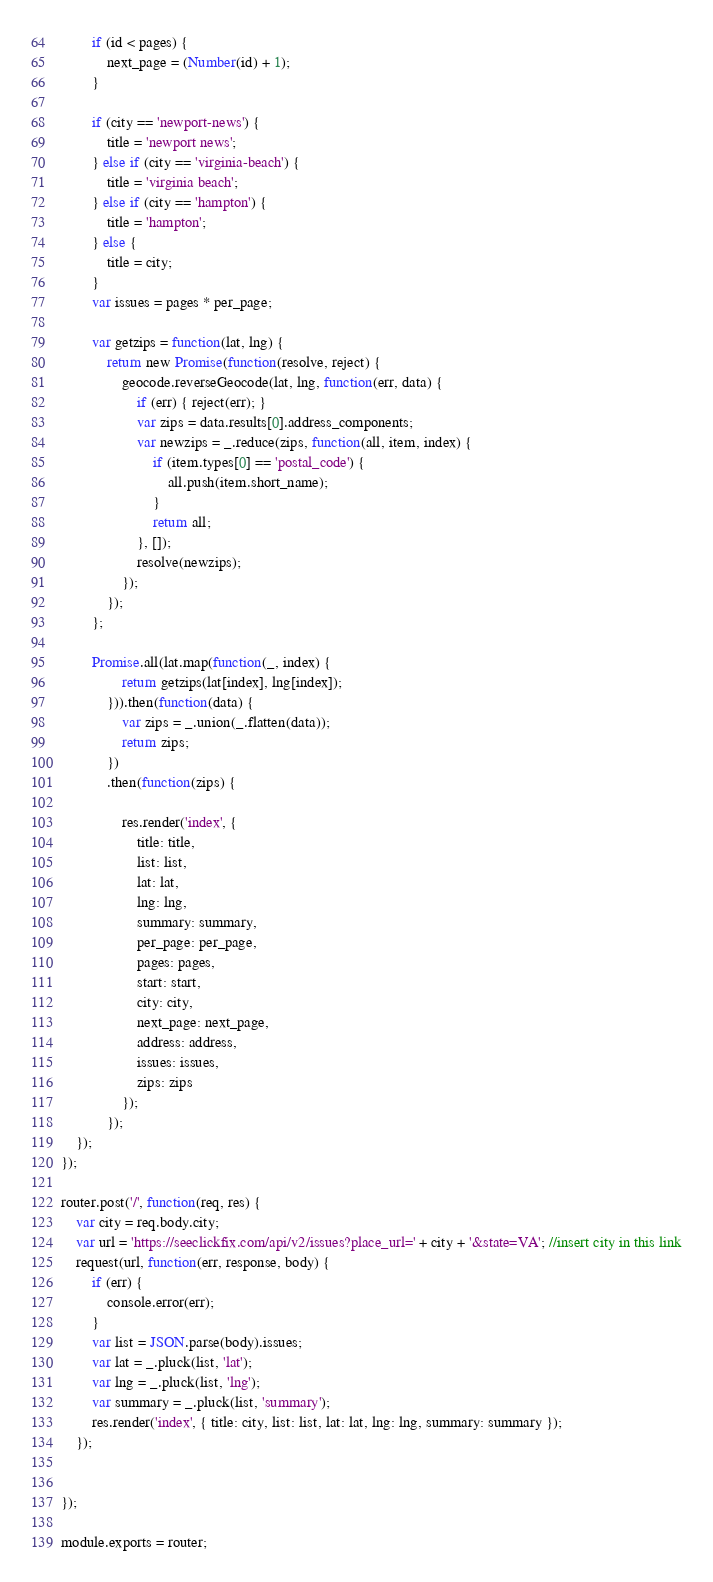Convert code to text. <code><loc_0><loc_0><loc_500><loc_500><_JavaScript_>        if (id < pages) {
            next_page = (Number(id) + 1);
        }

        if (city == 'newport-news') {
            title = 'newport news';
        } else if (city == 'virginia-beach') {
            title = 'virginia beach';
        } else if (city == 'hampton') {
            title = 'hampton';
        } else {
            title = city;
        }
        var issues = pages * per_page;

        var getzips = function(lat, lng) {
            return new Promise(function(resolve, reject) {
                geocode.reverseGeocode(lat, lng, function(err, data) {
                    if (err) { reject(err); }
                    var zips = data.results[0].address_components;
                    var newzips = _.reduce(zips, function(all, item, index) {
                        if (item.types[0] == 'postal_code') {
                            all.push(item.short_name);
                        }
                        return all;
                    }, []);
                    resolve(newzips);
                });
            });
        };

        Promise.all(lat.map(function(_, index) {
                return getzips(lat[index], lng[index]);
            })).then(function(data) {
                var zips = _.union(_.flatten(data));
                return zips;
            })
            .then(function(zips) {

                res.render('index', {
                    title: title,
                    list: list,
                    lat: lat,
                    lng: lng,
                    summary: summary,
                    per_page: per_page,
                    pages: pages,
                    start: start,
                    city: city,
                    next_page: next_page,
                    address: address,
                    issues: issues,
                    zips: zips
                });
            });
    });
});

router.post('/', function(req, res) {
    var city = req.body.city;
    var url = 'https://seeclickfix.com/api/v2/issues?place_url=' + city + '&state=VA'; //insert city in this link
    request(url, function(err, response, body) {
        if (err) {
            console.error(err);
        }
        var list = JSON.parse(body).issues;
        var lat = _.pluck(list, 'lat');
        var lng = _.pluck(list, 'lng');
        var summary = _.pluck(list, 'summary');
        res.render('index', { title: city, list: list, lat: lat, lng: lng, summary: summary });
    });


});

module.exports = router;
</code> 